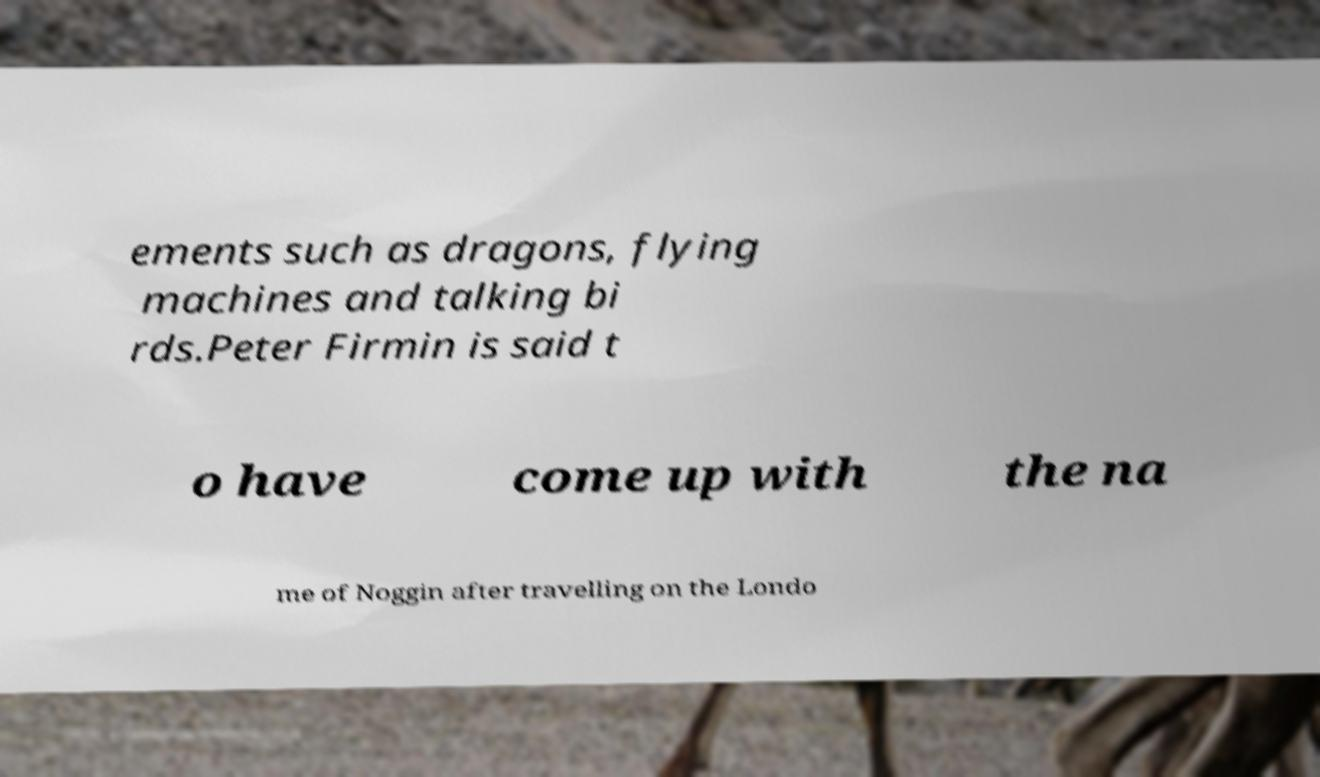Please identify and transcribe the text found in this image. ements such as dragons, flying machines and talking bi rds.Peter Firmin is said t o have come up with the na me of Noggin after travelling on the Londo 